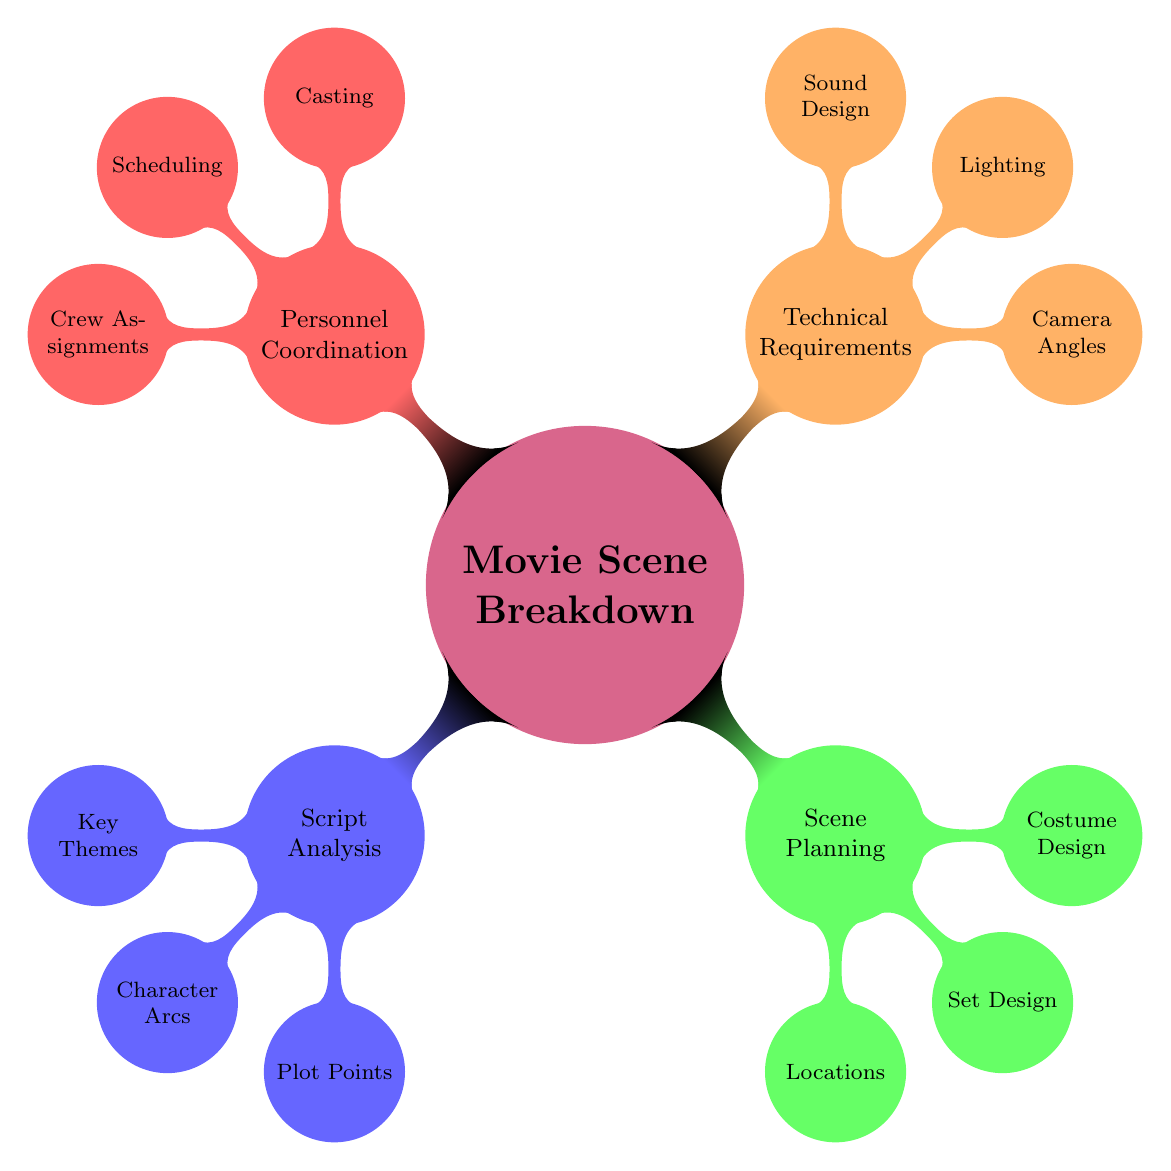What are the key themes identified in the script analysis? The diagram lists "Justice, Morality, Betrayal" under the "Key Themes" node within "Script Analysis."
Answer: Justice, Morality, Betrayal How many main categories are there in the mind map? The main categories are the four primary child nodes branching from "Movie Scene Breakdown": "Script Analysis," "Scene Planning," "Technical Requirements," and "Personnel Coordination." There are four categories in total.
Answer: 4 Which location is associated with "Set Design"? The "Set Design" node is connected to the "Scene Planning" category, which outlines the 1980s university setting and a high-ceiling library.
Answer: Authentic 1980s University Setting Who plays the protagonist according to the casting section? Within the "Casting" node under "Personnel Coordination," it specifies that "Nominated Actor - John Doe" is assigned to the protagonist role.
Answer: Nominated Actor - John Doe What type of lighting is required for outdoor scenes? The "Lighting" node in the "Technical Requirements" section states that "Natural light" is to be used for outdoor scenes.
Answer: Natural light How do the camera angles contribute to scene planning? The "Camera Angles" node suggests using "Close-up" for emotional expressions and "Wide shot" for context, indicating specific uses for creating impact in scenes through technical choices.
Answer: Close-up, Wide shot In which phase of personnel coordination is scene rehearsals mentioned? The "Scene Rehearsals" are part of the "Scheduling" node in "Personnel Coordination," detailing when rehearsals will take place.
Answer: Weekly sessions What is the climax identified in the script analysis? The "Significant Plot Points" under "Script Analysis" describes the "Climax" as the "Face-off between Protagonist and Antagonist."
Answer: Face-off between Protagonist and Antagonist What design style is indicated for the antagonist's costume? In the "Costume Design" section of "Scene Planning," it states that the "Antagonist" will wear a "Sharp Business Suit."
Answer: Sharp Business Suit 